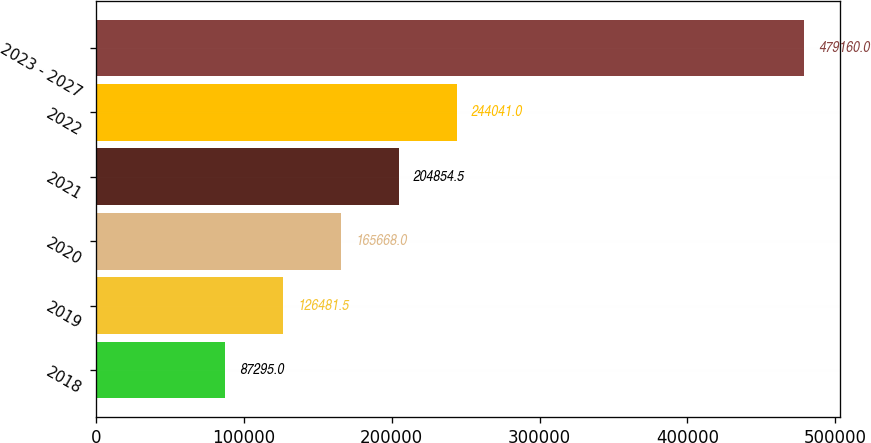Convert chart. <chart><loc_0><loc_0><loc_500><loc_500><bar_chart><fcel>2018<fcel>2019<fcel>2020<fcel>2021<fcel>2022<fcel>2023 - 2027<nl><fcel>87295<fcel>126482<fcel>165668<fcel>204854<fcel>244041<fcel>479160<nl></chart> 